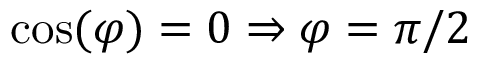Convert formula to latex. <formula><loc_0><loc_0><loc_500><loc_500>\cos ( \varphi ) = 0 \Rightarrow \varphi = \pi / 2</formula> 